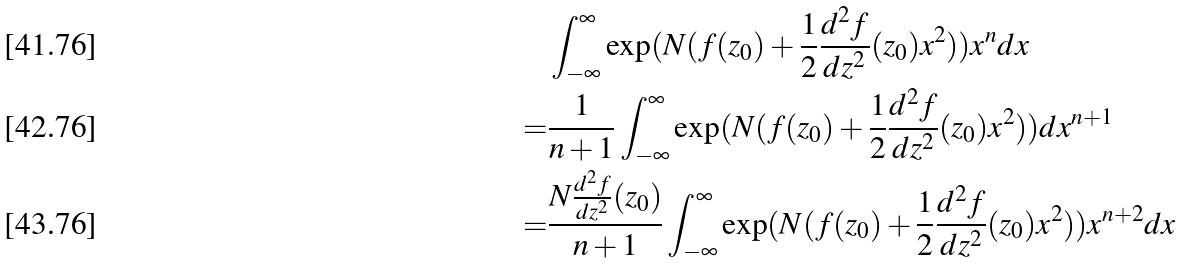Convert formula to latex. <formula><loc_0><loc_0><loc_500><loc_500>& \int _ { - \infty } ^ { \infty } \exp ( N ( f ( z _ { 0 } ) + \frac { 1 } { 2 } \frac { d ^ { 2 } f } { d z ^ { 2 } } ( z _ { 0 } ) x ^ { 2 } ) ) x ^ { n } d x \\ = & \frac { 1 } { n + 1 } \int _ { - \infty } ^ { \infty } \exp ( N ( f ( z _ { 0 } ) + \frac { 1 } { 2 } \frac { d ^ { 2 } f } { d z ^ { 2 } } ( z _ { 0 } ) x ^ { 2 } ) ) d x ^ { n + 1 } \\ = & \frac { N \frac { d ^ { 2 } f } { d z ^ { 2 } } ( z _ { 0 } ) } { n + 1 } \int _ { - \infty } ^ { \infty } \exp ( N ( f ( z _ { 0 } ) + \frac { 1 } { 2 } \frac { d ^ { 2 } f } { d z ^ { 2 } } ( z _ { 0 } ) x ^ { 2 } ) ) x ^ { n + 2 } d x</formula> 